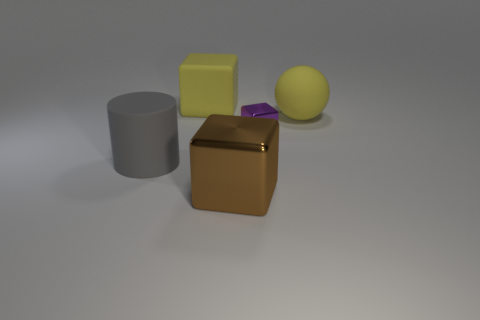Add 2 tiny metallic objects. How many objects exist? 7 Subtract all cubes. How many objects are left? 2 Add 5 tiny green rubber cylinders. How many tiny green rubber cylinders exist? 5 Subtract 1 yellow spheres. How many objects are left? 4 Subtract all gray cylinders. Subtract all big red cylinders. How many objects are left? 4 Add 3 gray matte cylinders. How many gray matte cylinders are left? 4 